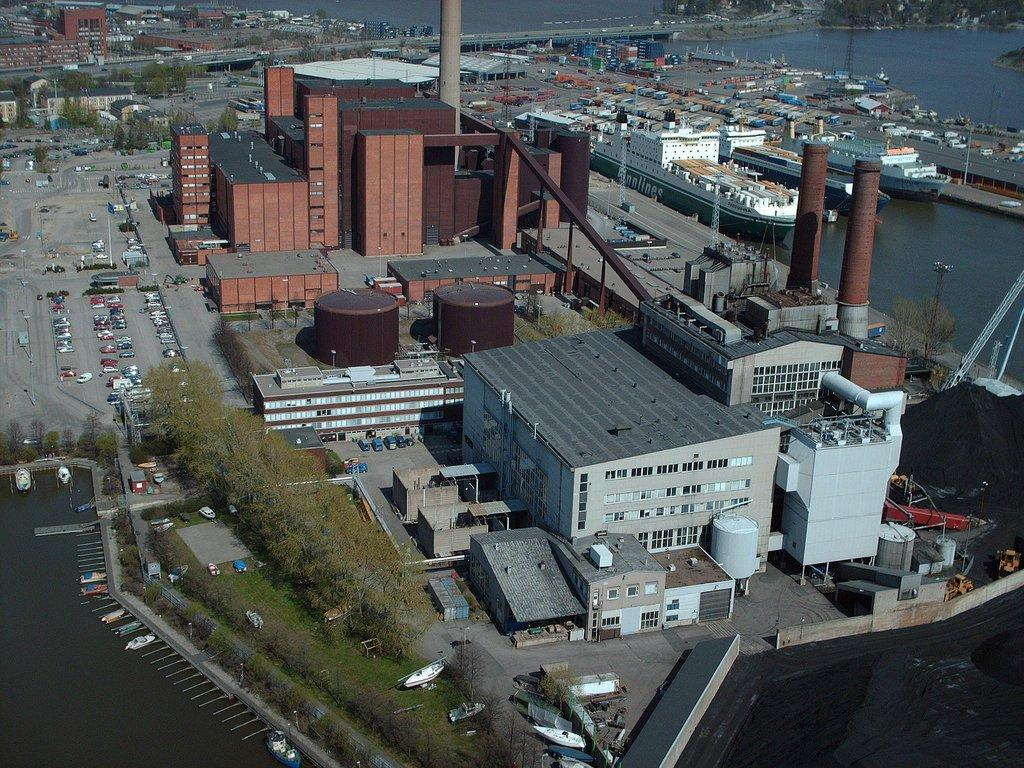What is the main subject in the center of the image? There are buildings in the center of the image. What other objects can be seen in the image? There are ships in the image. What else is visible around the area of the image? There are buildings around the area of the image. What type of finger can be seen in the image? There are no fingers present in the image. What place is depicted in the image? The image does not depict a specific place; it shows buildings and ships. 